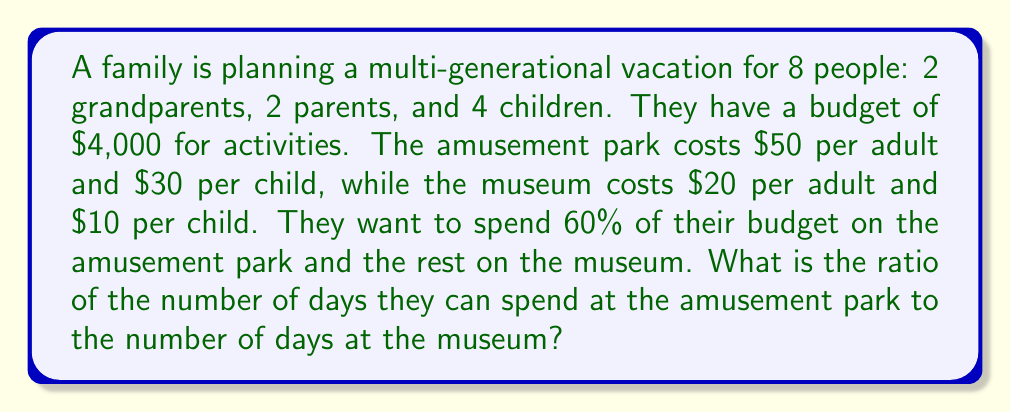What is the answer to this math problem? Let's solve this step-by-step:

1. Calculate the daily cost for each activity:
   Amusement park: $4 \cdot 50 + 4 \cdot 30 = $320$ per day
   Museum: $4 \cdot 20 + 4 \cdot 10 = $120$ per day

2. Calculate the budget for each activity:
   Amusement park: $60\% \text{ of } $4,000 = 0.6 \cdot 4000 = $2,400$
   Museum: $40\% \text{ of } $4,000 = 0.4 \cdot 4000 = $1,600$

3. Calculate the number of days for each activity:
   Amusement park: $\frac{$2,400}{$320\text{ per day}} = 7.5$ days
   Museum: $\frac{$1,600}{$120\text{ per day}} = 13.33$ days

4. Express the ratio of days at the amusement park to days at the museum:
   $\frac{7.5}{13.33} = \frac{15}{26.67} \approx \frac{9}{16}$

5. Simplify the ratio by dividing both numerator and denominator by their greatest common divisor (GCD):
   $GCD(9, 16) = 1$, so the ratio cannot be simplified further.

Therefore, the ratio of days at the amusement park to days at the museum is 9:16.
Answer: 9:16 